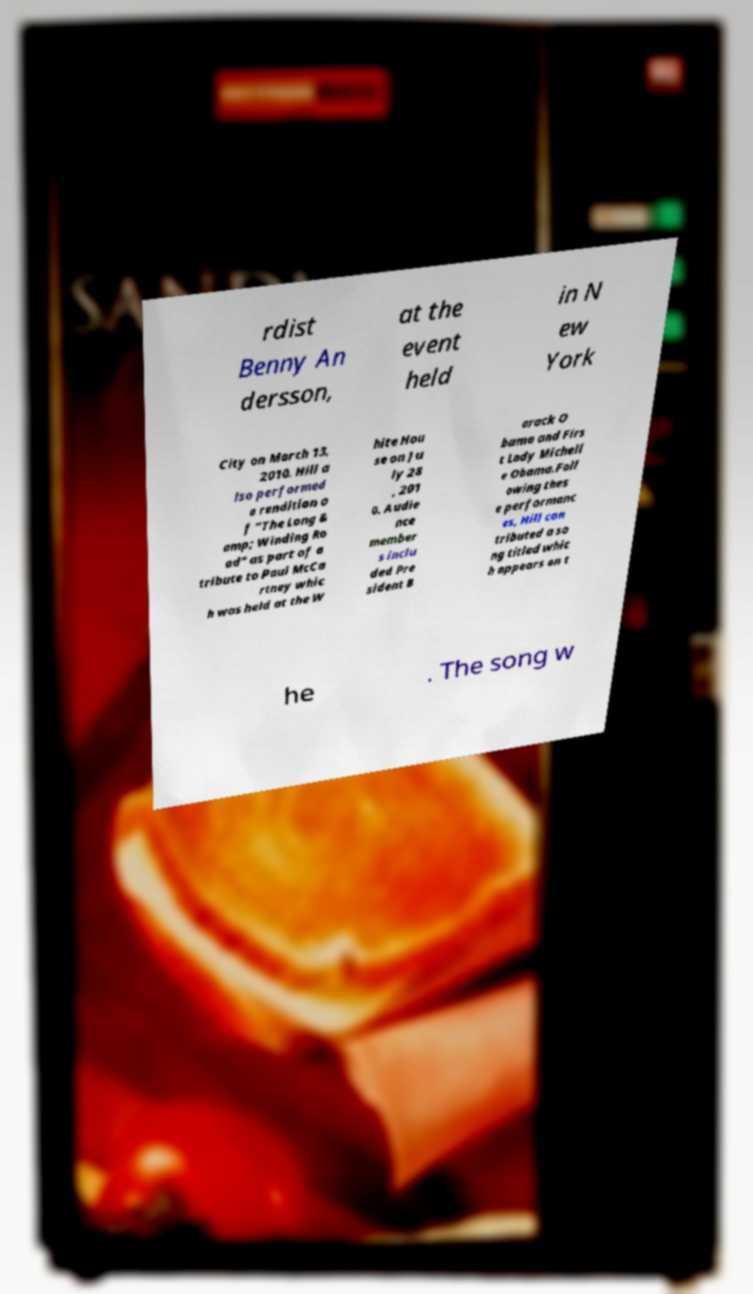What messages or text are displayed in this image? I need them in a readable, typed format. rdist Benny An dersson, at the event held in N ew York City on March 13, 2010. Hill a lso performed a rendition o f "The Long & amp; Winding Ro ad" as part of a tribute to Paul McCa rtney whic h was held at the W hite Hou se on Ju ly 28 , 201 0. Audie nce member s inclu ded Pre sident B arack O bama and Firs t Lady Michell e Obama.Foll owing thes e performanc es, Hill con tributed a so ng titled whic h appears on t he . The song w 